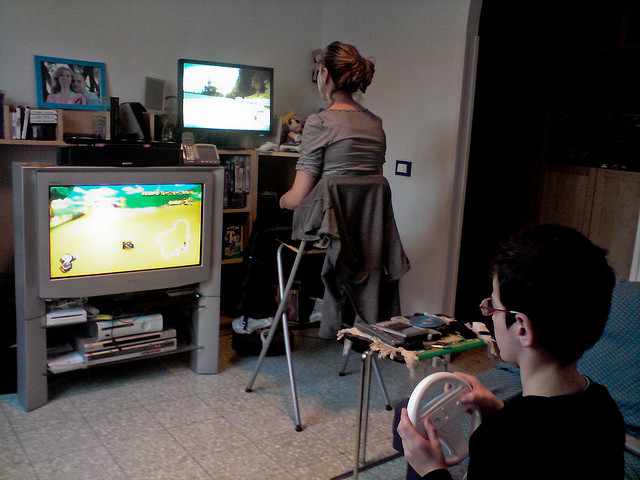<image>What virtual sport are they playing? I am not sure what virtual sport they are playing. It can be either racing or surfing. What virtual sport are they playing? I am not sure what virtual sport they are playing. It can be seen racing or surfing. 